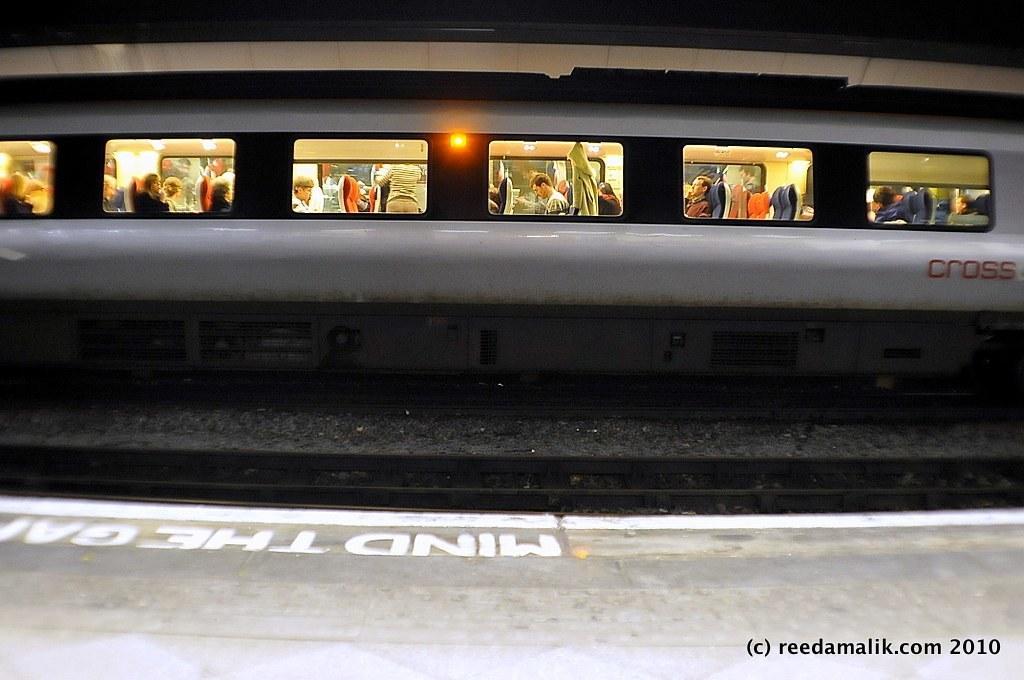Please provide a concise description of this image. In this picture I can see there is a train moving here and there are some people sitting inside the train and there are some windows and there are lights inside the train. There is a platform and a track here. 